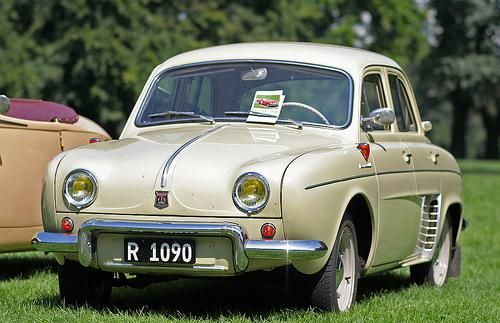Would there be a car in the image after the car disappeared from this picture? No 